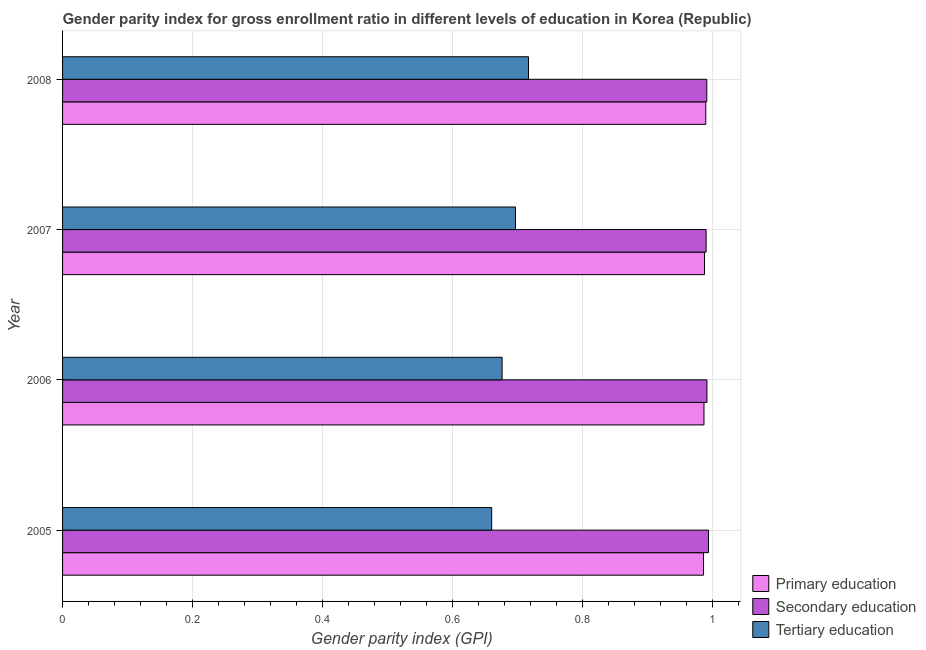How many different coloured bars are there?
Make the answer very short. 3. Are the number of bars per tick equal to the number of legend labels?
Provide a short and direct response. Yes. How many bars are there on the 4th tick from the top?
Your answer should be compact. 3. What is the label of the 2nd group of bars from the top?
Offer a terse response. 2007. In how many cases, is the number of bars for a given year not equal to the number of legend labels?
Offer a terse response. 0. What is the gender parity index in primary education in 2006?
Make the answer very short. 0.99. Across all years, what is the maximum gender parity index in primary education?
Give a very brief answer. 0.99. Across all years, what is the minimum gender parity index in secondary education?
Provide a succinct answer. 0.99. What is the total gender parity index in primary education in the graph?
Give a very brief answer. 3.95. What is the difference between the gender parity index in primary education in 2005 and that in 2006?
Offer a terse response. -0. What is the difference between the gender parity index in secondary education in 2008 and the gender parity index in primary education in 2005?
Offer a very short reply. 0.01. In the year 2005, what is the difference between the gender parity index in tertiary education and gender parity index in secondary education?
Ensure brevity in your answer.  -0.33. What is the ratio of the gender parity index in primary education in 2007 to that in 2008?
Keep it short and to the point. 1. Is the difference between the gender parity index in secondary education in 2005 and 2008 greater than the difference between the gender parity index in primary education in 2005 and 2008?
Your answer should be very brief. Yes. What is the difference between the highest and the lowest gender parity index in secondary education?
Your answer should be very brief. 0. What does the 2nd bar from the top in 2008 represents?
Offer a very short reply. Secondary education. What does the 3rd bar from the bottom in 2007 represents?
Make the answer very short. Tertiary education. Is it the case that in every year, the sum of the gender parity index in primary education and gender parity index in secondary education is greater than the gender parity index in tertiary education?
Ensure brevity in your answer.  Yes. How many bars are there?
Offer a terse response. 12. How many years are there in the graph?
Keep it short and to the point. 4. How many legend labels are there?
Your response must be concise. 3. What is the title of the graph?
Your answer should be compact. Gender parity index for gross enrollment ratio in different levels of education in Korea (Republic). Does "Social Protection" appear as one of the legend labels in the graph?
Keep it short and to the point. No. What is the label or title of the X-axis?
Your answer should be very brief. Gender parity index (GPI). What is the Gender parity index (GPI) of Primary education in 2005?
Give a very brief answer. 0.99. What is the Gender parity index (GPI) in Secondary education in 2005?
Make the answer very short. 0.99. What is the Gender parity index (GPI) in Tertiary education in 2005?
Your response must be concise. 0.66. What is the Gender parity index (GPI) of Primary education in 2006?
Provide a short and direct response. 0.99. What is the Gender parity index (GPI) in Secondary education in 2006?
Provide a short and direct response. 0.99. What is the Gender parity index (GPI) in Tertiary education in 2006?
Provide a short and direct response. 0.68. What is the Gender parity index (GPI) in Primary education in 2007?
Offer a very short reply. 0.99. What is the Gender parity index (GPI) in Secondary education in 2007?
Your answer should be compact. 0.99. What is the Gender parity index (GPI) in Tertiary education in 2007?
Offer a very short reply. 0.7. What is the Gender parity index (GPI) in Primary education in 2008?
Your response must be concise. 0.99. What is the Gender parity index (GPI) of Secondary education in 2008?
Ensure brevity in your answer.  0.99. What is the Gender parity index (GPI) of Tertiary education in 2008?
Keep it short and to the point. 0.72. Across all years, what is the maximum Gender parity index (GPI) in Primary education?
Offer a very short reply. 0.99. Across all years, what is the maximum Gender parity index (GPI) in Secondary education?
Give a very brief answer. 0.99. Across all years, what is the maximum Gender parity index (GPI) of Tertiary education?
Offer a very short reply. 0.72. Across all years, what is the minimum Gender parity index (GPI) of Primary education?
Your answer should be compact. 0.99. Across all years, what is the minimum Gender parity index (GPI) of Secondary education?
Your answer should be compact. 0.99. Across all years, what is the minimum Gender parity index (GPI) in Tertiary education?
Your response must be concise. 0.66. What is the total Gender parity index (GPI) of Primary education in the graph?
Make the answer very short. 3.95. What is the total Gender parity index (GPI) of Secondary education in the graph?
Offer a very short reply. 3.97. What is the total Gender parity index (GPI) of Tertiary education in the graph?
Provide a succinct answer. 2.75. What is the difference between the Gender parity index (GPI) of Primary education in 2005 and that in 2006?
Keep it short and to the point. -0. What is the difference between the Gender parity index (GPI) in Secondary education in 2005 and that in 2006?
Your response must be concise. 0. What is the difference between the Gender parity index (GPI) of Tertiary education in 2005 and that in 2006?
Offer a very short reply. -0.02. What is the difference between the Gender parity index (GPI) in Primary education in 2005 and that in 2007?
Offer a terse response. -0. What is the difference between the Gender parity index (GPI) of Secondary education in 2005 and that in 2007?
Provide a short and direct response. 0. What is the difference between the Gender parity index (GPI) of Tertiary education in 2005 and that in 2007?
Your response must be concise. -0.04. What is the difference between the Gender parity index (GPI) of Primary education in 2005 and that in 2008?
Ensure brevity in your answer.  -0. What is the difference between the Gender parity index (GPI) in Secondary education in 2005 and that in 2008?
Give a very brief answer. 0. What is the difference between the Gender parity index (GPI) in Tertiary education in 2005 and that in 2008?
Keep it short and to the point. -0.06. What is the difference between the Gender parity index (GPI) in Primary education in 2006 and that in 2007?
Offer a terse response. -0. What is the difference between the Gender parity index (GPI) in Secondary education in 2006 and that in 2007?
Give a very brief answer. 0. What is the difference between the Gender parity index (GPI) of Tertiary education in 2006 and that in 2007?
Give a very brief answer. -0.02. What is the difference between the Gender parity index (GPI) of Primary education in 2006 and that in 2008?
Provide a succinct answer. -0. What is the difference between the Gender parity index (GPI) in Secondary education in 2006 and that in 2008?
Offer a very short reply. 0. What is the difference between the Gender parity index (GPI) of Tertiary education in 2006 and that in 2008?
Offer a very short reply. -0.04. What is the difference between the Gender parity index (GPI) in Primary education in 2007 and that in 2008?
Keep it short and to the point. -0. What is the difference between the Gender parity index (GPI) of Secondary education in 2007 and that in 2008?
Your answer should be compact. -0. What is the difference between the Gender parity index (GPI) of Tertiary education in 2007 and that in 2008?
Provide a succinct answer. -0.02. What is the difference between the Gender parity index (GPI) in Primary education in 2005 and the Gender parity index (GPI) in Secondary education in 2006?
Offer a terse response. -0.01. What is the difference between the Gender parity index (GPI) in Primary education in 2005 and the Gender parity index (GPI) in Tertiary education in 2006?
Ensure brevity in your answer.  0.31. What is the difference between the Gender parity index (GPI) in Secondary education in 2005 and the Gender parity index (GPI) in Tertiary education in 2006?
Make the answer very short. 0.32. What is the difference between the Gender parity index (GPI) in Primary education in 2005 and the Gender parity index (GPI) in Secondary education in 2007?
Make the answer very short. -0. What is the difference between the Gender parity index (GPI) of Primary education in 2005 and the Gender parity index (GPI) of Tertiary education in 2007?
Provide a short and direct response. 0.29. What is the difference between the Gender parity index (GPI) of Secondary education in 2005 and the Gender parity index (GPI) of Tertiary education in 2007?
Your response must be concise. 0.3. What is the difference between the Gender parity index (GPI) in Primary education in 2005 and the Gender parity index (GPI) in Secondary education in 2008?
Keep it short and to the point. -0.01. What is the difference between the Gender parity index (GPI) of Primary education in 2005 and the Gender parity index (GPI) of Tertiary education in 2008?
Offer a very short reply. 0.27. What is the difference between the Gender parity index (GPI) of Secondary education in 2005 and the Gender parity index (GPI) of Tertiary education in 2008?
Your answer should be compact. 0.28. What is the difference between the Gender parity index (GPI) in Primary education in 2006 and the Gender parity index (GPI) in Secondary education in 2007?
Your answer should be very brief. -0. What is the difference between the Gender parity index (GPI) in Primary education in 2006 and the Gender parity index (GPI) in Tertiary education in 2007?
Keep it short and to the point. 0.29. What is the difference between the Gender parity index (GPI) in Secondary education in 2006 and the Gender parity index (GPI) in Tertiary education in 2007?
Your response must be concise. 0.29. What is the difference between the Gender parity index (GPI) in Primary education in 2006 and the Gender parity index (GPI) in Secondary education in 2008?
Make the answer very short. -0. What is the difference between the Gender parity index (GPI) in Primary education in 2006 and the Gender parity index (GPI) in Tertiary education in 2008?
Provide a succinct answer. 0.27. What is the difference between the Gender parity index (GPI) in Secondary education in 2006 and the Gender parity index (GPI) in Tertiary education in 2008?
Make the answer very short. 0.27. What is the difference between the Gender parity index (GPI) of Primary education in 2007 and the Gender parity index (GPI) of Secondary education in 2008?
Provide a short and direct response. -0. What is the difference between the Gender parity index (GPI) of Primary education in 2007 and the Gender parity index (GPI) of Tertiary education in 2008?
Provide a short and direct response. 0.27. What is the difference between the Gender parity index (GPI) of Secondary education in 2007 and the Gender parity index (GPI) of Tertiary education in 2008?
Give a very brief answer. 0.27. What is the average Gender parity index (GPI) of Primary education per year?
Offer a terse response. 0.99. What is the average Gender parity index (GPI) in Secondary education per year?
Offer a terse response. 0.99. What is the average Gender parity index (GPI) in Tertiary education per year?
Provide a succinct answer. 0.69. In the year 2005, what is the difference between the Gender parity index (GPI) in Primary education and Gender parity index (GPI) in Secondary education?
Your answer should be compact. -0.01. In the year 2005, what is the difference between the Gender parity index (GPI) of Primary education and Gender parity index (GPI) of Tertiary education?
Offer a very short reply. 0.33. In the year 2005, what is the difference between the Gender parity index (GPI) of Secondary education and Gender parity index (GPI) of Tertiary education?
Your answer should be very brief. 0.33. In the year 2006, what is the difference between the Gender parity index (GPI) in Primary education and Gender parity index (GPI) in Secondary education?
Ensure brevity in your answer.  -0. In the year 2006, what is the difference between the Gender parity index (GPI) in Primary education and Gender parity index (GPI) in Tertiary education?
Provide a succinct answer. 0.31. In the year 2006, what is the difference between the Gender parity index (GPI) of Secondary education and Gender parity index (GPI) of Tertiary education?
Your response must be concise. 0.32. In the year 2007, what is the difference between the Gender parity index (GPI) in Primary education and Gender parity index (GPI) in Secondary education?
Your answer should be compact. -0. In the year 2007, what is the difference between the Gender parity index (GPI) in Primary education and Gender parity index (GPI) in Tertiary education?
Your answer should be compact. 0.29. In the year 2007, what is the difference between the Gender parity index (GPI) of Secondary education and Gender parity index (GPI) of Tertiary education?
Ensure brevity in your answer.  0.29. In the year 2008, what is the difference between the Gender parity index (GPI) in Primary education and Gender parity index (GPI) in Secondary education?
Your answer should be very brief. -0. In the year 2008, what is the difference between the Gender parity index (GPI) of Primary education and Gender parity index (GPI) of Tertiary education?
Ensure brevity in your answer.  0.27. In the year 2008, what is the difference between the Gender parity index (GPI) in Secondary education and Gender parity index (GPI) in Tertiary education?
Provide a short and direct response. 0.27. What is the ratio of the Gender parity index (GPI) in Primary education in 2005 to that in 2006?
Offer a very short reply. 1. What is the ratio of the Gender parity index (GPI) in Secondary education in 2005 to that in 2006?
Your response must be concise. 1. What is the ratio of the Gender parity index (GPI) in Tertiary education in 2005 to that in 2006?
Provide a short and direct response. 0.98. What is the ratio of the Gender parity index (GPI) of Tertiary education in 2005 to that in 2007?
Make the answer very short. 0.95. What is the ratio of the Gender parity index (GPI) of Secondary education in 2005 to that in 2008?
Ensure brevity in your answer.  1. What is the ratio of the Gender parity index (GPI) in Tertiary education in 2005 to that in 2008?
Your answer should be very brief. 0.92. What is the ratio of the Gender parity index (GPI) in Primary education in 2006 to that in 2007?
Offer a very short reply. 1. What is the ratio of the Gender parity index (GPI) in Tertiary education in 2006 to that in 2007?
Keep it short and to the point. 0.97. What is the ratio of the Gender parity index (GPI) of Primary education in 2006 to that in 2008?
Offer a very short reply. 1. What is the ratio of the Gender parity index (GPI) in Secondary education in 2006 to that in 2008?
Make the answer very short. 1. What is the ratio of the Gender parity index (GPI) in Tertiary education in 2006 to that in 2008?
Your response must be concise. 0.94. What is the ratio of the Gender parity index (GPI) in Secondary education in 2007 to that in 2008?
Your response must be concise. 1. What is the difference between the highest and the second highest Gender parity index (GPI) in Primary education?
Provide a short and direct response. 0. What is the difference between the highest and the second highest Gender parity index (GPI) of Secondary education?
Your answer should be compact. 0. What is the difference between the highest and the lowest Gender parity index (GPI) in Primary education?
Provide a succinct answer. 0. What is the difference between the highest and the lowest Gender parity index (GPI) in Secondary education?
Your response must be concise. 0. What is the difference between the highest and the lowest Gender parity index (GPI) in Tertiary education?
Provide a succinct answer. 0.06. 